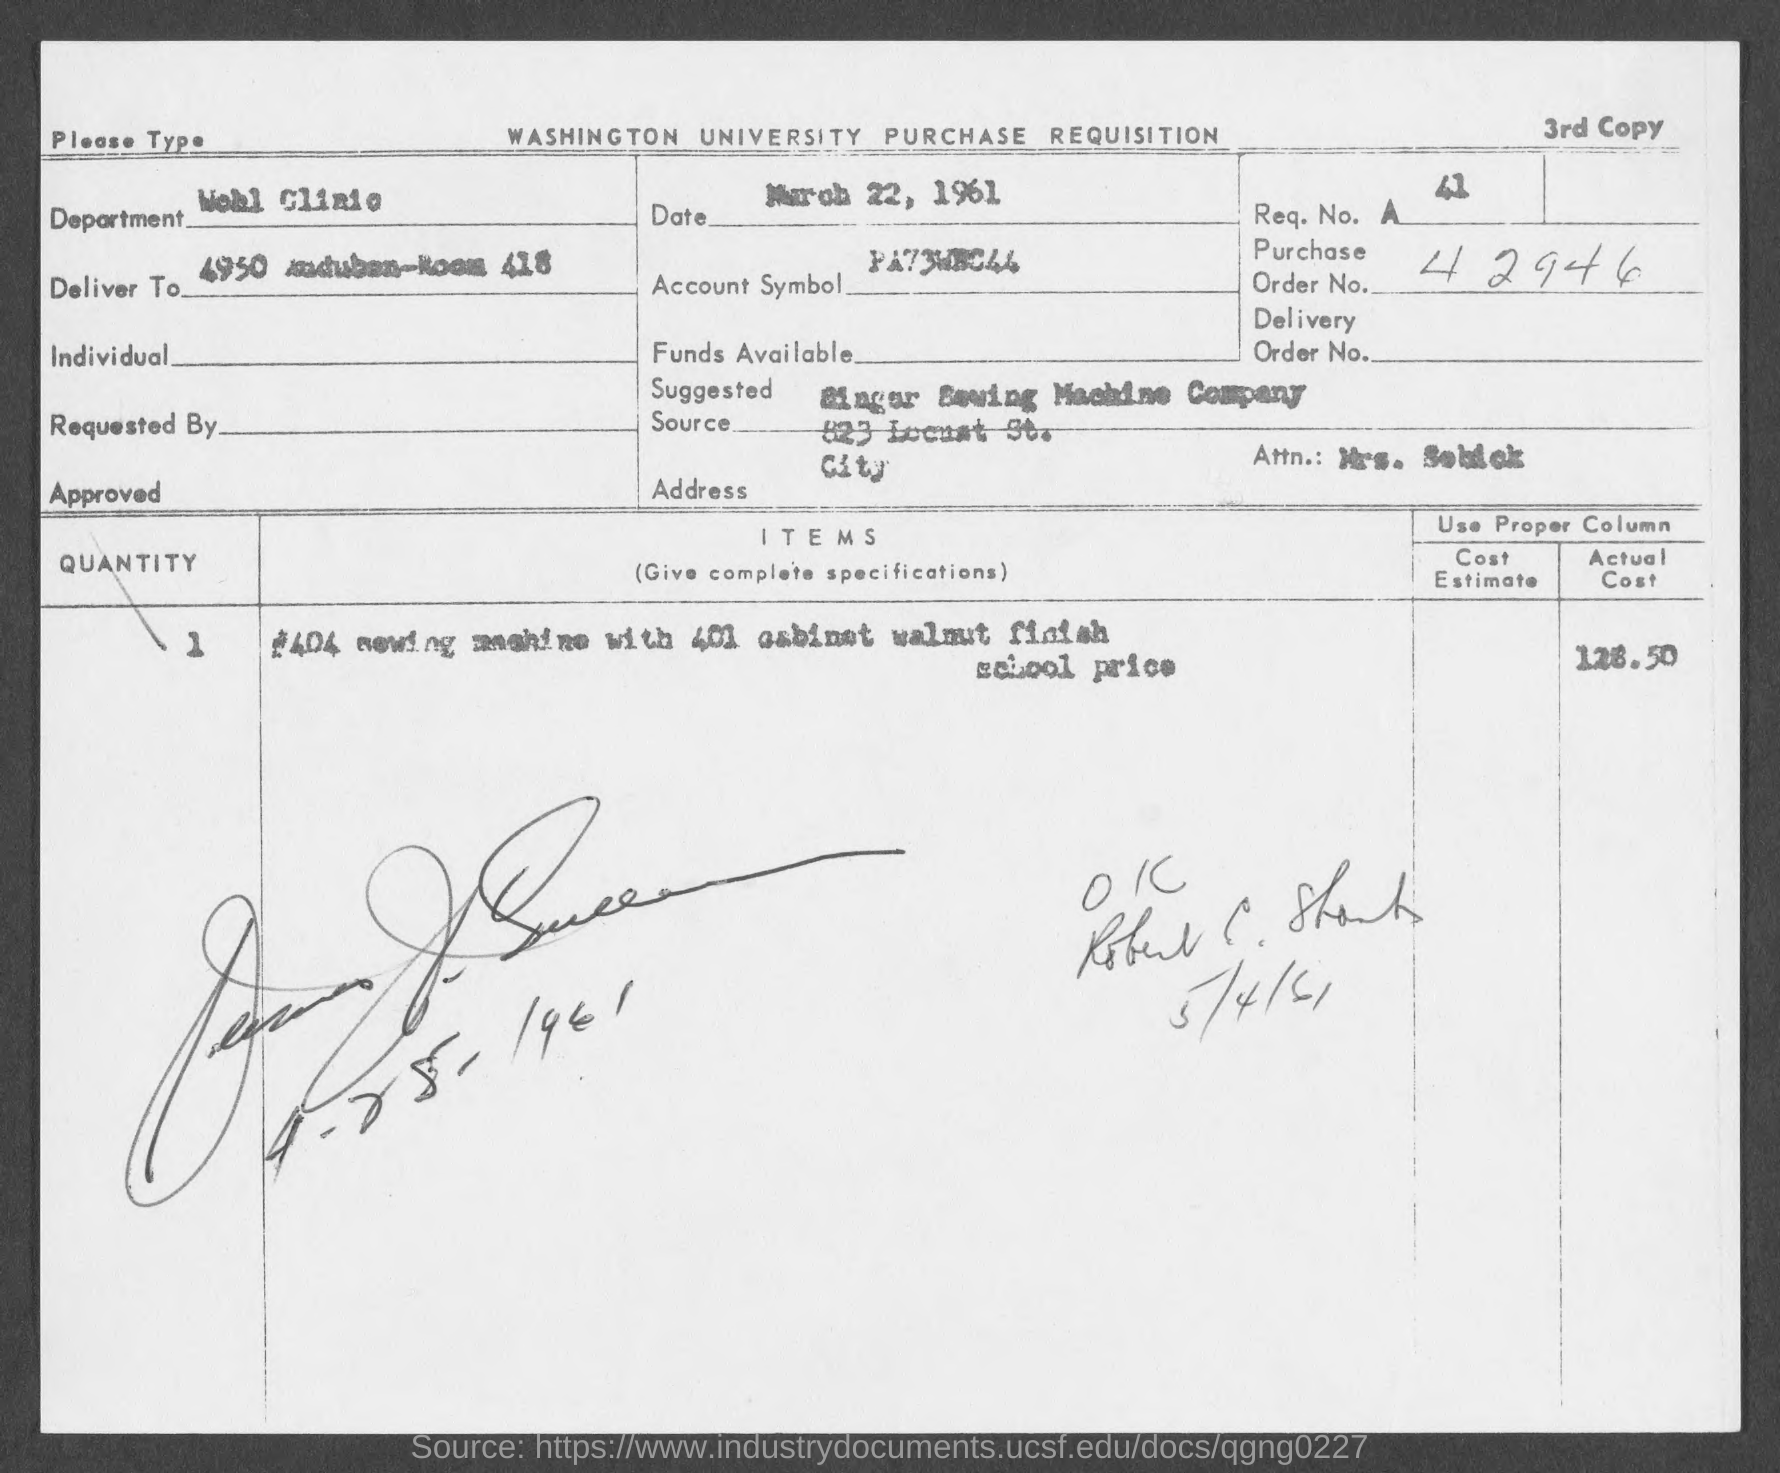What is the purchase order no.?
Your response must be concise. 42946. 